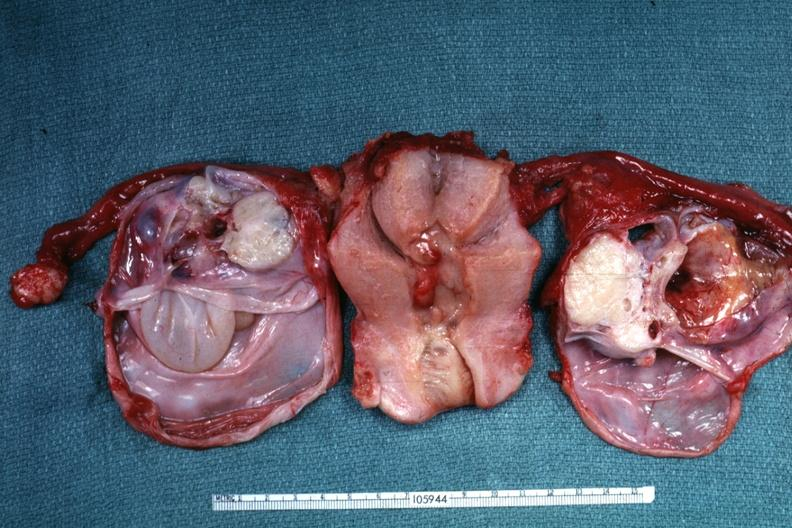what have same as except ovaries been cut of tumor masses?
Answer the question using a single word or phrase. Been to show multiloculated nature 